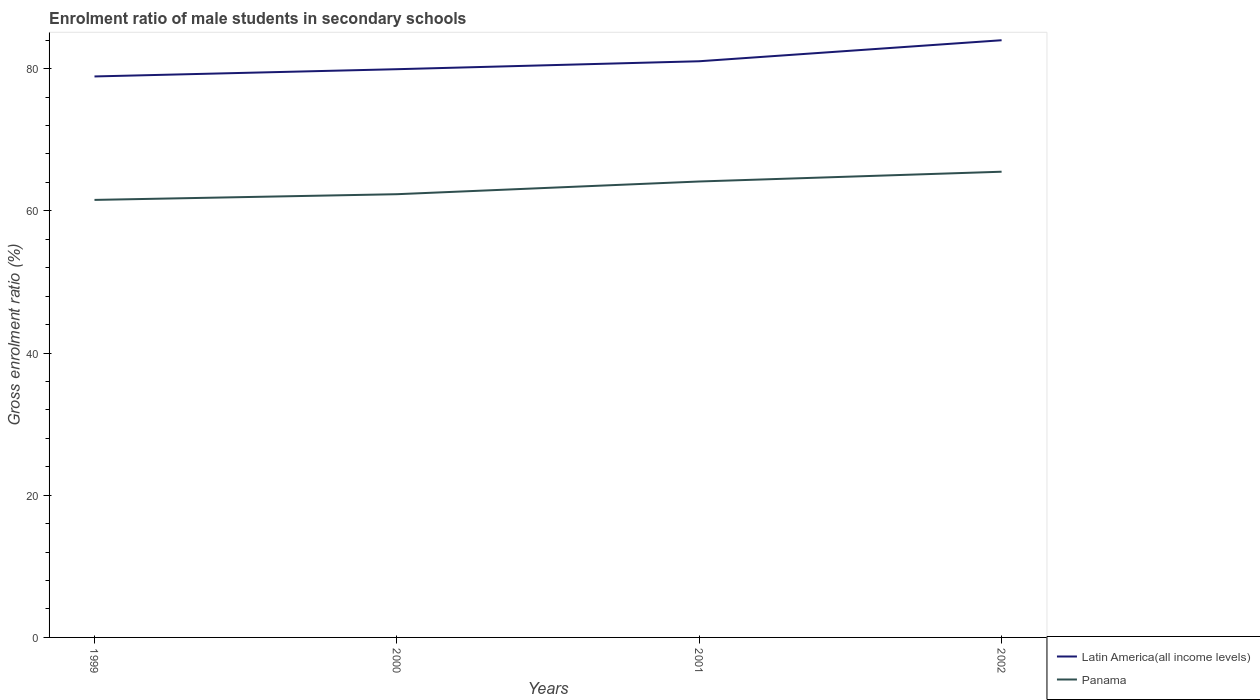Across all years, what is the maximum enrolment ratio of male students in secondary schools in Panama?
Ensure brevity in your answer.  61.54. In which year was the enrolment ratio of male students in secondary schools in Latin America(all income levels) maximum?
Provide a short and direct response. 1999. What is the total enrolment ratio of male students in secondary schools in Latin America(all income levels) in the graph?
Ensure brevity in your answer.  -4.08. What is the difference between the highest and the second highest enrolment ratio of male students in secondary schools in Latin America(all income levels)?
Your answer should be compact. 5.09. What is the difference between the highest and the lowest enrolment ratio of male students in secondary schools in Panama?
Ensure brevity in your answer.  2. Is the enrolment ratio of male students in secondary schools in Panama strictly greater than the enrolment ratio of male students in secondary schools in Latin America(all income levels) over the years?
Offer a terse response. Yes. How many lines are there?
Make the answer very short. 2. What is the difference between two consecutive major ticks on the Y-axis?
Your answer should be compact. 20. Are the values on the major ticks of Y-axis written in scientific E-notation?
Your answer should be compact. No. Does the graph contain any zero values?
Offer a very short reply. No. Does the graph contain grids?
Offer a terse response. No. Where does the legend appear in the graph?
Provide a short and direct response. Bottom right. How many legend labels are there?
Offer a very short reply. 2. How are the legend labels stacked?
Give a very brief answer. Vertical. What is the title of the graph?
Make the answer very short. Enrolment ratio of male students in secondary schools. Does "Greece" appear as one of the legend labels in the graph?
Ensure brevity in your answer.  No. What is the label or title of the X-axis?
Your answer should be very brief. Years. What is the Gross enrolment ratio (%) in Latin America(all income levels) in 1999?
Provide a succinct answer. 78.9. What is the Gross enrolment ratio (%) in Panama in 1999?
Offer a terse response. 61.54. What is the Gross enrolment ratio (%) in Latin America(all income levels) in 2000?
Ensure brevity in your answer.  79.92. What is the Gross enrolment ratio (%) in Panama in 2000?
Offer a terse response. 62.34. What is the Gross enrolment ratio (%) in Latin America(all income levels) in 2001?
Offer a terse response. 81.04. What is the Gross enrolment ratio (%) in Panama in 2001?
Provide a succinct answer. 64.13. What is the Gross enrolment ratio (%) in Latin America(all income levels) in 2002?
Your answer should be very brief. 83.99. What is the Gross enrolment ratio (%) of Panama in 2002?
Make the answer very short. 65.5. Across all years, what is the maximum Gross enrolment ratio (%) of Latin America(all income levels)?
Your response must be concise. 83.99. Across all years, what is the maximum Gross enrolment ratio (%) of Panama?
Ensure brevity in your answer.  65.5. Across all years, what is the minimum Gross enrolment ratio (%) in Latin America(all income levels)?
Your answer should be compact. 78.9. Across all years, what is the minimum Gross enrolment ratio (%) in Panama?
Offer a terse response. 61.54. What is the total Gross enrolment ratio (%) in Latin America(all income levels) in the graph?
Your answer should be very brief. 323.85. What is the total Gross enrolment ratio (%) in Panama in the graph?
Give a very brief answer. 253.5. What is the difference between the Gross enrolment ratio (%) in Latin America(all income levels) in 1999 and that in 2000?
Provide a short and direct response. -1.02. What is the difference between the Gross enrolment ratio (%) of Panama in 1999 and that in 2000?
Give a very brief answer. -0.8. What is the difference between the Gross enrolment ratio (%) of Latin America(all income levels) in 1999 and that in 2001?
Your answer should be very brief. -2.14. What is the difference between the Gross enrolment ratio (%) in Panama in 1999 and that in 2001?
Make the answer very short. -2.59. What is the difference between the Gross enrolment ratio (%) of Latin America(all income levels) in 1999 and that in 2002?
Offer a very short reply. -5.09. What is the difference between the Gross enrolment ratio (%) in Panama in 1999 and that in 2002?
Give a very brief answer. -3.96. What is the difference between the Gross enrolment ratio (%) of Latin America(all income levels) in 2000 and that in 2001?
Keep it short and to the point. -1.12. What is the difference between the Gross enrolment ratio (%) of Panama in 2000 and that in 2001?
Keep it short and to the point. -1.79. What is the difference between the Gross enrolment ratio (%) of Latin America(all income levels) in 2000 and that in 2002?
Offer a terse response. -4.08. What is the difference between the Gross enrolment ratio (%) of Panama in 2000 and that in 2002?
Keep it short and to the point. -3.16. What is the difference between the Gross enrolment ratio (%) of Latin America(all income levels) in 2001 and that in 2002?
Ensure brevity in your answer.  -2.96. What is the difference between the Gross enrolment ratio (%) in Panama in 2001 and that in 2002?
Your answer should be compact. -1.37. What is the difference between the Gross enrolment ratio (%) in Latin America(all income levels) in 1999 and the Gross enrolment ratio (%) in Panama in 2000?
Provide a short and direct response. 16.56. What is the difference between the Gross enrolment ratio (%) of Latin America(all income levels) in 1999 and the Gross enrolment ratio (%) of Panama in 2001?
Provide a short and direct response. 14.77. What is the difference between the Gross enrolment ratio (%) in Latin America(all income levels) in 1999 and the Gross enrolment ratio (%) in Panama in 2002?
Provide a short and direct response. 13.4. What is the difference between the Gross enrolment ratio (%) of Latin America(all income levels) in 2000 and the Gross enrolment ratio (%) of Panama in 2001?
Give a very brief answer. 15.79. What is the difference between the Gross enrolment ratio (%) in Latin America(all income levels) in 2000 and the Gross enrolment ratio (%) in Panama in 2002?
Your response must be concise. 14.42. What is the difference between the Gross enrolment ratio (%) of Latin America(all income levels) in 2001 and the Gross enrolment ratio (%) of Panama in 2002?
Your answer should be very brief. 15.54. What is the average Gross enrolment ratio (%) of Latin America(all income levels) per year?
Offer a terse response. 80.96. What is the average Gross enrolment ratio (%) of Panama per year?
Offer a terse response. 63.38. In the year 1999, what is the difference between the Gross enrolment ratio (%) of Latin America(all income levels) and Gross enrolment ratio (%) of Panama?
Offer a very short reply. 17.36. In the year 2000, what is the difference between the Gross enrolment ratio (%) of Latin America(all income levels) and Gross enrolment ratio (%) of Panama?
Your answer should be compact. 17.58. In the year 2001, what is the difference between the Gross enrolment ratio (%) of Latin America(all income levels) and Gross enrolment ratio (%) of Panama?
Give a very brief answer. 16.91. In the year 2002, what is the difference between the Gross enrolment ratio (%) of Latin America(all income levels) and Gross enrolment ratio (%) of Panama?
Provide a succinct answer. 18.49. What is the ratio of the Gross enrolment ratio (%) in Latin America(all income levels) in 1999 to that in 2000?
Offer a very short reply. 0.99. What is the ratio of the Gross enrolment ratio (%) of Panama in 1999 to that in 2000?
Your answer should be compact. 0.99. What is the ratio of the Gross enrolment ratio (%) in Latin America(all income levels) in 1999 to that in 2001?
Provide a short and direct response. 0.97. What is the ratio of the Gross enrolment ratio (%) in Panama in 1999 to that in 2001?
Give a very brief answer. 0.96. What is the ratio of the Gross enrolment ratio (%) in Latin America(all income levels) in 1999 to that in 2002?
Ensure brevity in your answer.  0.94. What is the ratio of the Gross enrolment ratio (%) in Panama in 1999 to that in 2002?
Keep it short and to the point. 0.94. What is the ratio of the Gross enrolment ratio (%) of Latin America(all income levels) in 2000 to that in 2001?
Provide a succinct answer. 0.99. What is the ratio of the Gross enrolment ratio (%) in Panama in 2000 to that in 2001?
Offer a very short reply. 0.97. What is the ratio of the Gross enrolment ratio (%) of Latin America(all income levels) in 2000 to that in 2002?
Provide a succinct answer. 0.95. What is the ratio of the Gross enrolment ratio (%) of Panama in 2000 to that in 2002?
Make the answer very short. 0.95. What is the ratio of the Gross enrolment ratio (%) in Latin America(all income levels) in 2001 to that in 2002?
Your answer should be very brief. 0.96. What is the ratio of the Gross enrolment ratio (%) of Panama in 2001 to that in 2002?
Keep it short and to the point. 0.98. What is the difference between the highest and the second highest Gross enrolment ratio (%) of Latin America(all income levels)?
Make the answer very short. 2.96. What is the difference between the highest and the second highest Gross enrolment ratio (%) of Panama?
Provide a succinct answer. 1.37. What is the difference between the highest and the lowest Gross enrolment ratio (%) of Latin America(all income levels)?
Make the answer very short. 5.09. What is the difference between the highest and the lowest Gross enrolment ratio (%) of Panama?
Your answer should be compact. 3.96. 